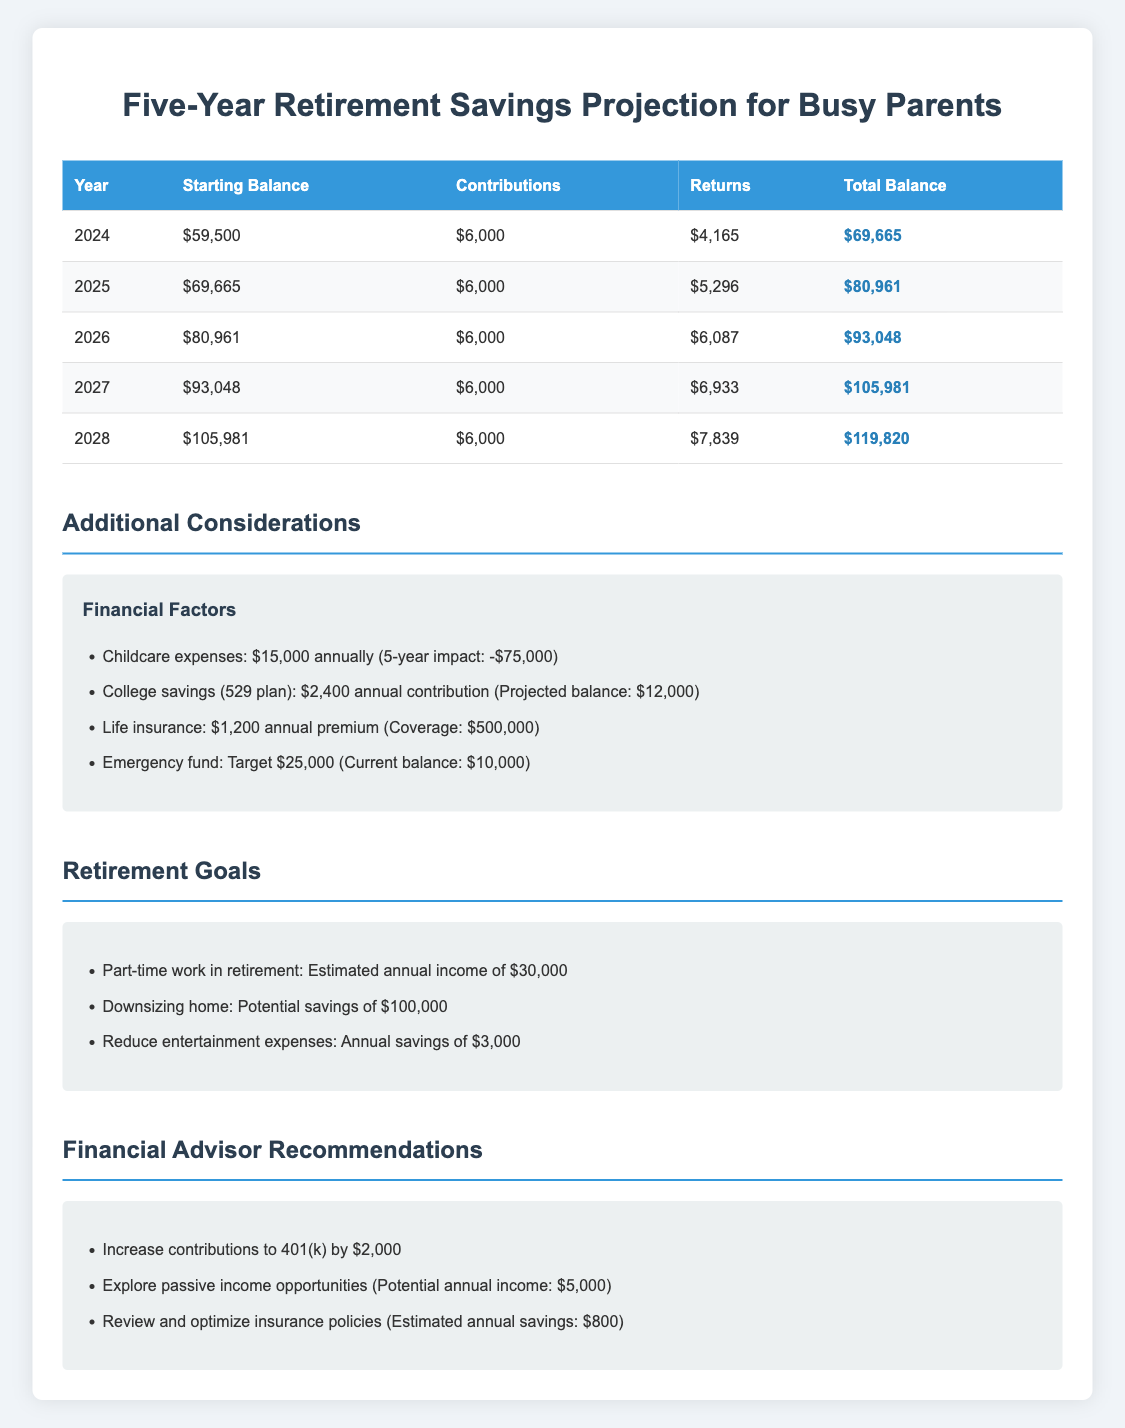What was the total balance in 2026? In the table, under the row for the year 2026, the total balance is listed as $93,048.
Answer: $93,048 What is the total amount contributed by the end of 2028? The annual contribution is $6,000, and there are 5 years of contributions (2024 to 2028), so the total contributions are calculated as $6,000 * 5 = $30,000.
Answer: $30,000 Did the total balance increase from 2025 to 2026? Reviewing the total balance for 2025, which is $80,961, and for 2026, which is $93,048, shows that the balance increased by $93,048 - $80,961 = $12,087. Therefore, the total balance did increase.
Answer: Yes What is the percentage increase of the total balance from 2024 to 2028? The total balance in 2024 is $69,665 and in 2028 is $119,820. The increase is $119,820 - $69,665 = $50,155. To find the percentage increase, apply the formula: (increase/original)*100, so ($50,155/$69,665)*100 = 72.0%.
Answer: 72.0% What are the average annual returns over the five years projected? The returns for each year are $4,165, $5,296, $6,087, $6,933, and $7,839. The total returns are $4,165 + $5,296 + $6,087 + $6,933 + $7,839 = $30,320. To find the average, divide by the number of years: $30,320 / 5 = $6,064.
Answer: $6,064 How much did the savings grow from 2024 to 2027? The savings in 2024 are $59,500, and in 2027, they are $105,981. The growth is calculated as $105,981 - $59,500 = $46,481, showing significant growth over the three years.
Answer: $46,481 Is the projected annual return for 2025 greater than 5,000? The projected annual return for 2025 is $5,296, which is greater than 5,000.
Answer: Yes What will be the total balance after contributions in 2025? In 2025, the total balance before considering contributions is $69,665. By adding the contribution of $6,000, the total after contributions would be $69,665 + $6,000 = $75,665.
Answer: $75,665 